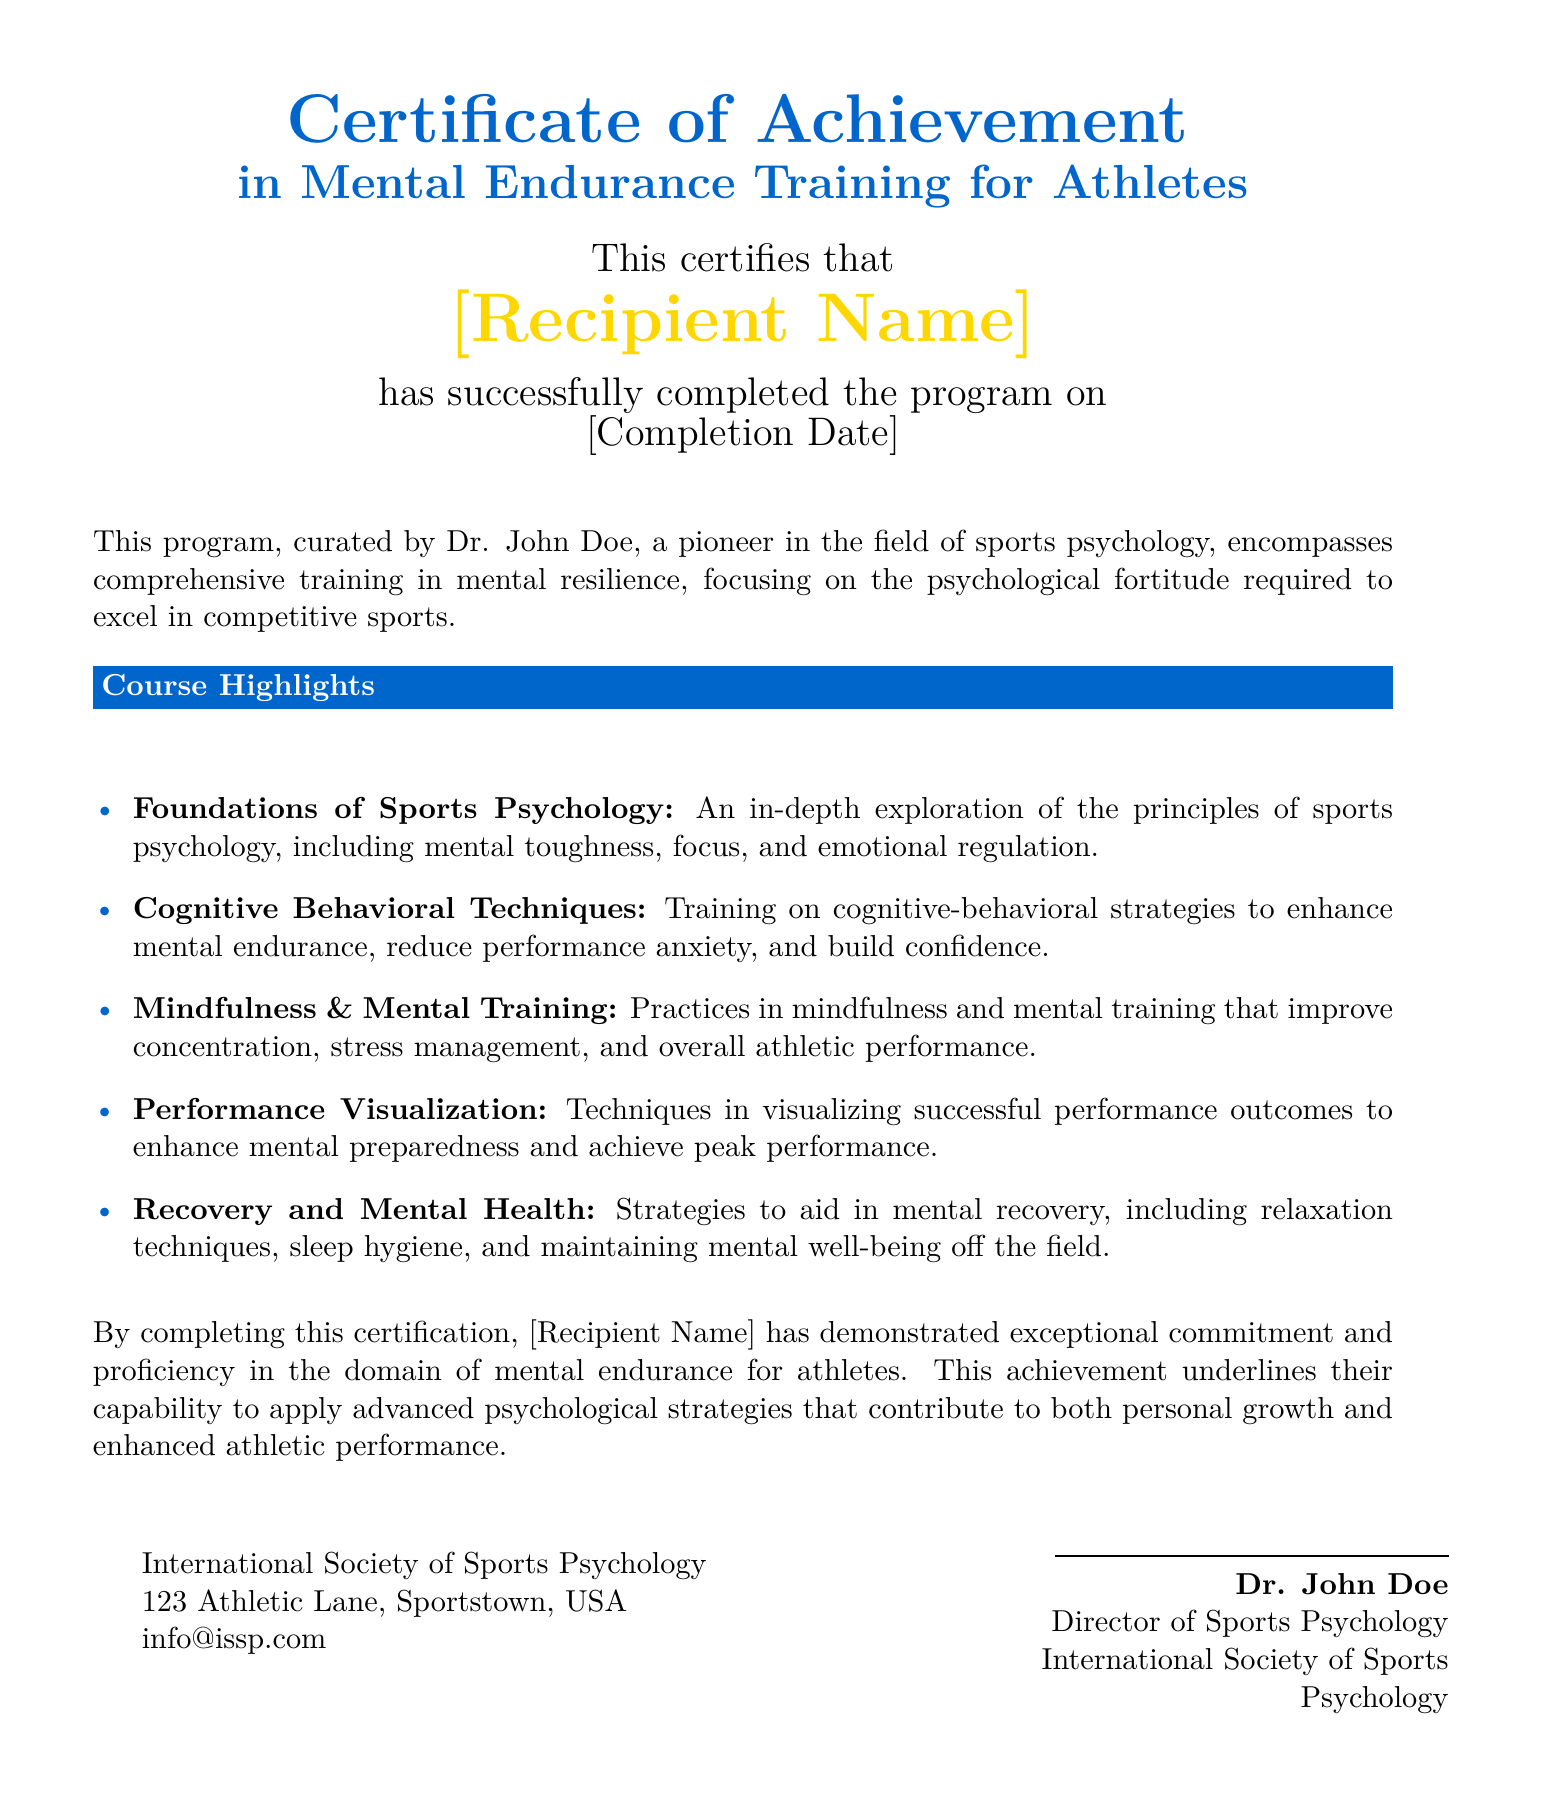What is the title of the certificate? The title of the certificate is prominently displayed at the top of the document.
Answer: Certificate of Achievement in Mental Endurance Training for Athletes Who curated the program? The program is curated by Dr. John Doe, whose name is mentioned in the context of the certificate.
Answer: Dr. John Doe What color is used for the section titles? The section titles are displayed in a specific color that is consistently applied throughout the document.
Answer: sportblue What date is referenced in the certificate? The completion date is a crucial piece of information indicated on the certificate for the recipient.
Answer: [Completion Date] What skill is emphasized in the course highlights related to mental recovery? One of the categories described in the course highlights focuses on techniques that support mental recovery.
Answer: Relaxation techniques What organization awarded this certificate? The organization credited with this achievement is clearly stated at the bottom of the document.
Answer: International Society of Sports Psychology What psychological strategies are mentioned for enhancing performance? The document lists several strategies aimed at improving athletic performance as part of the curriculum.
Answer: Performance Visualization What does the certificate indicate about the recipient's commitment? The document highlights the recipient's dedication to the field through specific phrasing about their accomplishments.
Answer: Exceptional commitment and proficiency 